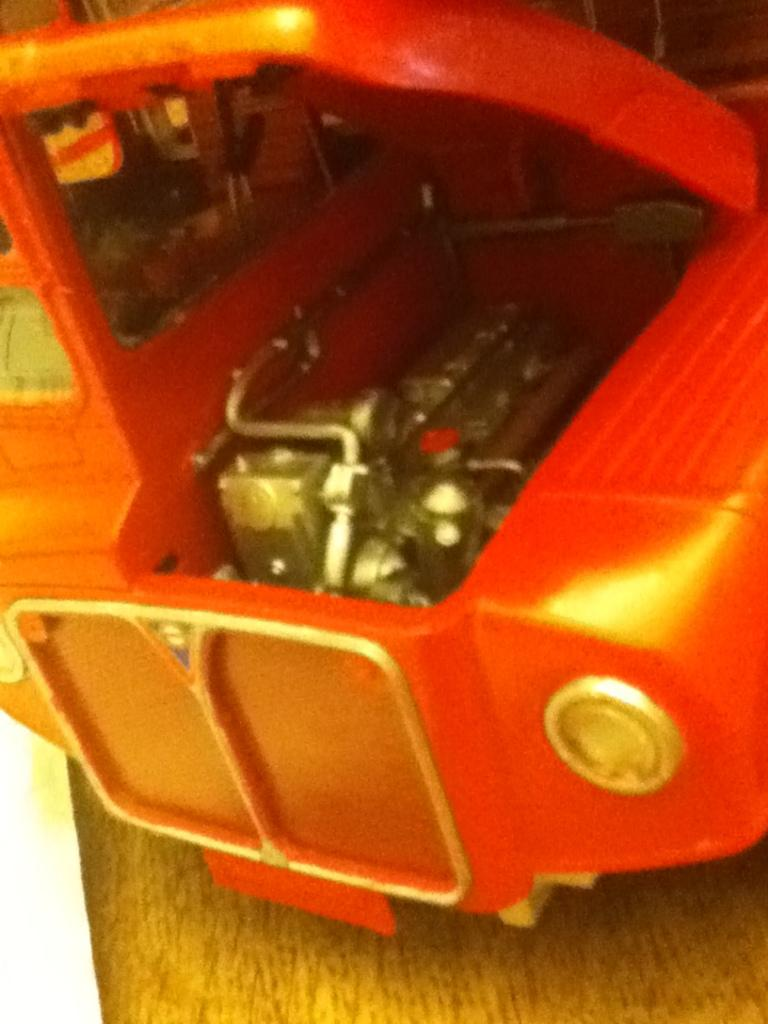What is the main subject of the image? The main subject of the image is a toy car. Can you describe the color of the toy car? The toy car is orange in color. What else can be seen in the image besides the toy car? There are some unspecified objects in the image. What type of underwear is the toy car wearing in the image? The toy car is not wearing any underwear, as it is an inanimate object and not capable of wearing clothing. 